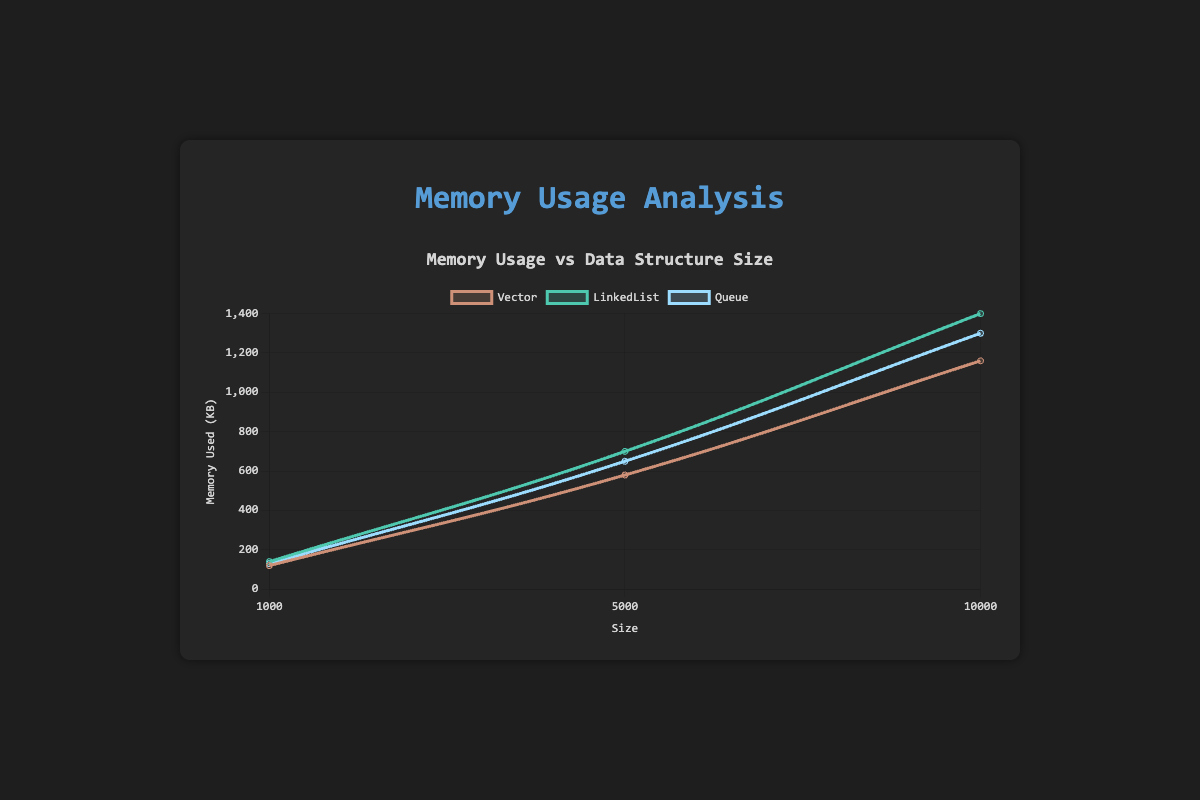What data structure uses the most memory at the largest size? Compare the memory usage at size 10,000 for all data structures. The vector uses 1160 KB, the linked list uses 1400 KB, and the queue uses 1300 KB. The linked list uses the most memory.
Answer: Linked list Which data structure has the least memory usage at size 1000? Compare the memory usage at size 1000 for all data structures. The vector uses 120 KB, the linked list uses 140 KB, and the queue uses 130 KB. The vector uses the least memory.
Answer: Vector By how much does the memory usage of the linked list increase from size 1000 to 5000? Subtract the memory usage at size 1000 from the memory usage at size 5000 for the linked list. 700 KB - 140 KB = 560 KB.
Answer: 560 KB On average, how much more memory does the queue use compared to the vector? Calculate the average memory usage for both the queue and the vector, then find the difference. For the queue ((130 + 650 + 1300) / 3) = 693.33 KB, and for the vector ((120 + 580 + 1160) / 3) = 620 KB. The difference is 693.33 KB - 620 KB = 73.33 KB.
Answer: 73.33 KB Which data structure shows the most consistent increase in memory usage over time? Compare the linearity of the increase in memory usage for each data structure. The vector goes from 120 KB to 580 KB to 1160 KB (consistent linear increase), the linked list from 140 KB to 700 KB to 1400 KB (consistent linear increase), and the queue from 130 KB to 650 KB to 1300 KB (consistent linear increase). All data structures show consistent increases, but the vector and linked list have near-identical memory increments, whereas the queue is slightly less smooth with minor increments
Answer: Vector and Linked list 